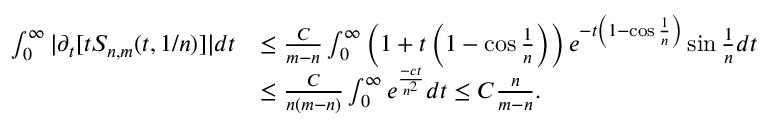<formula> <loc_0><loc_0><loc_500><loc_500>\begin{array} { r l } { \int _ { 0 } ^ { \infty } | \partial _ { t } [ t S _ { n , m } ( t , { 1 } / { n } ) ] | d t } & { \leq \frac { C } { m - n } \int _ { 0 } ^ { \infty } \left ( 1 + t \left ( 1 - \cos \frac { 1 } { n } \right ) \right ) e ^ { - t \left ( 1 - \cos \frac { 1 } { n } \right ) } \sin \frac { 1 } { n } d t } \\ & { \leq \frac { C } { n ( m - n ) } \int _ { 0 } ^ { \infty } e ^ { \frac { - c t } { n ^ { 2 } } } d t \leq C \frac { n } { m - n } . } \end{array}</formula> 